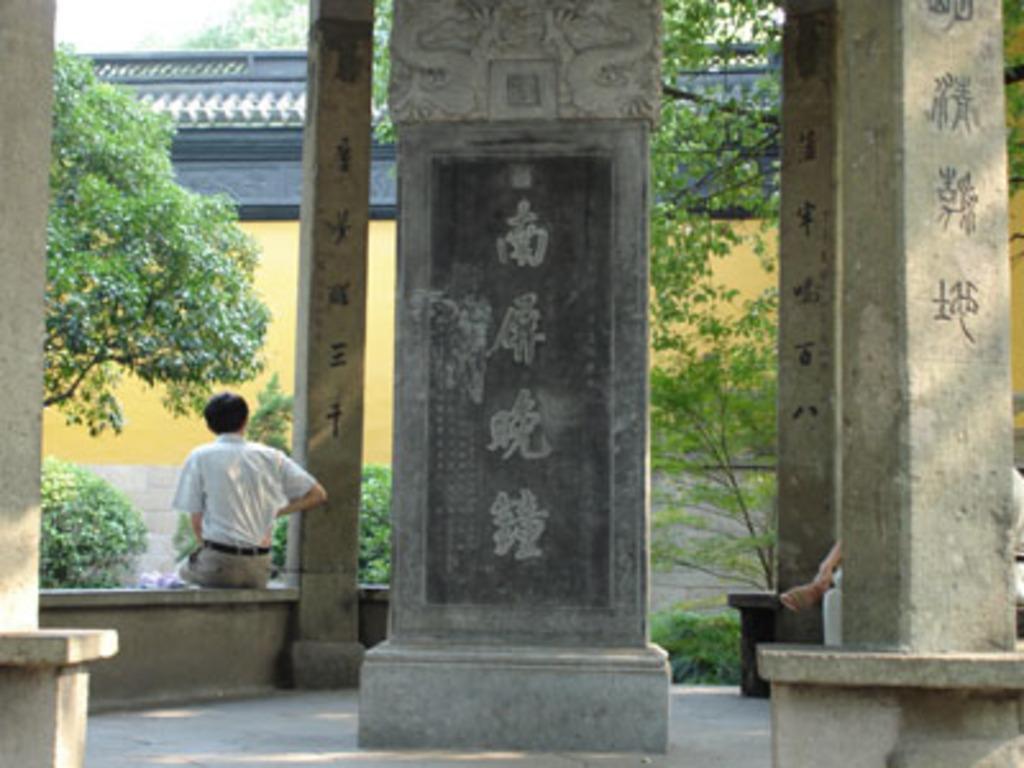Can you describe this image briefly? In the picture I can see the pillars and there are snake designs on the pillars. There is a man on the left side is wearing a shirt. I can see a person on the right side, though face is not visible. In the background, I can see the house and trees. 